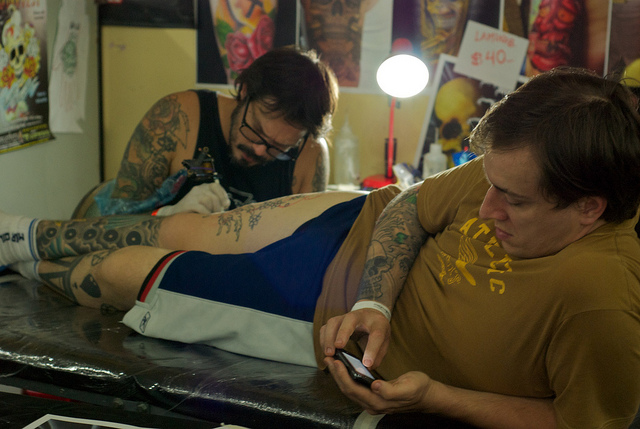Describe the tattoo on the man's leg. The tattoo on the man's leg appears to be a complex design with dark shading and intricate patterns, possibly depicting organic or floral elements mixed with geometric shapes, adding an artistic touch to his collection of body art. 